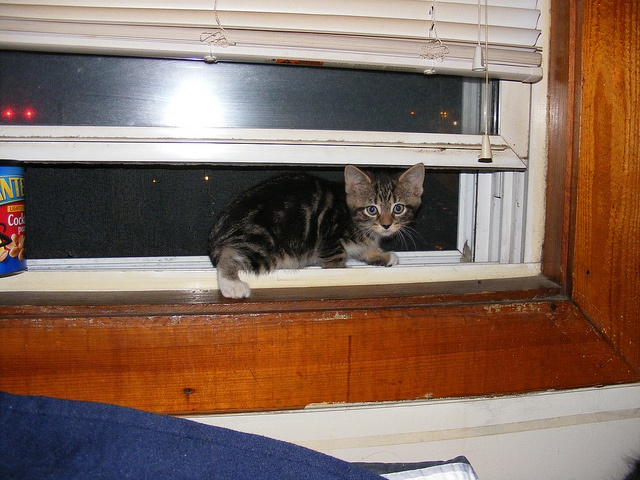Describe the objects in this image and their specific colors. I can see a cat in darkgray, black, and gray tones in this image. 